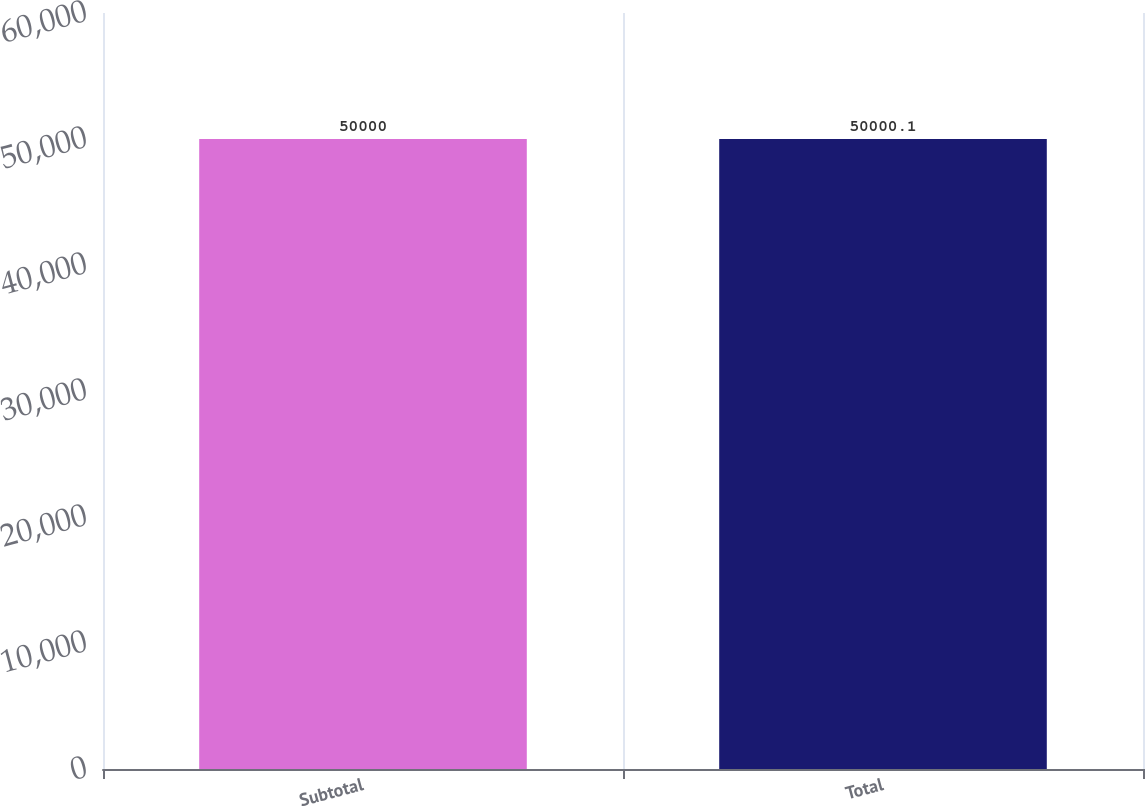<chart> <loc_0><loc_0><loc_500><loc_500><bar_chart><fcel>Subtotal<fcel>Total<nl><fcel>50000<fcel>50000.1<nl></chart> 